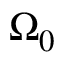<formula> <loc_0><loc_0><loc_500><loc_500>\Omega _ { 0 }</formula> 